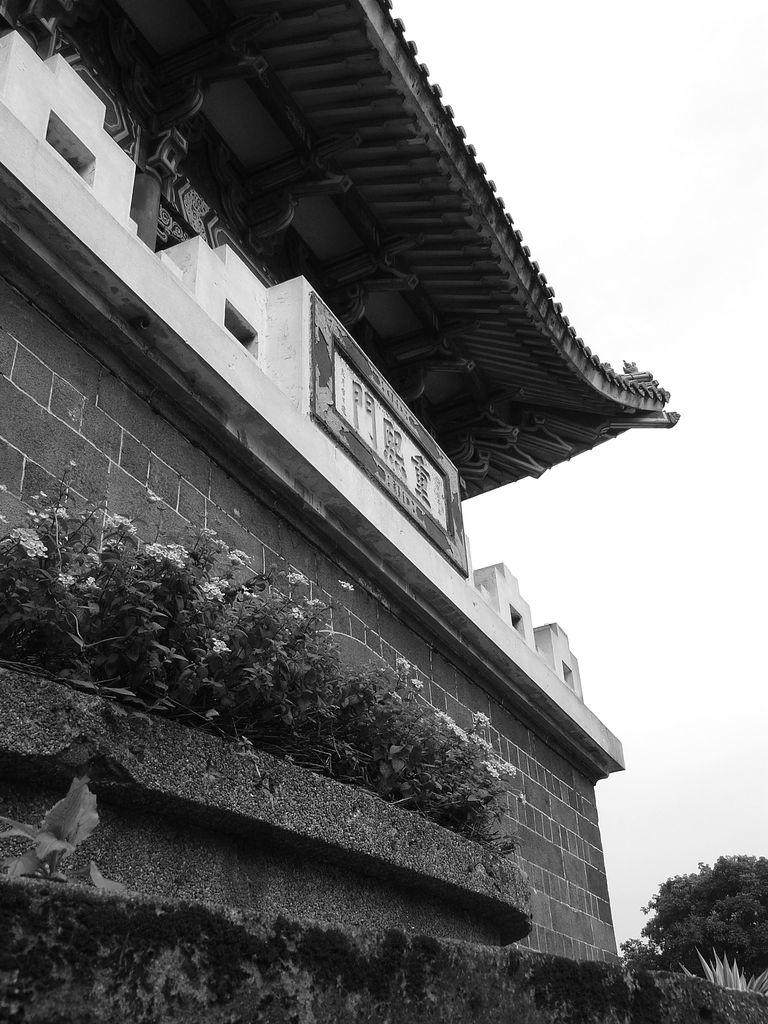What type of structure is present in the image? There is a building in the image. What is located in front of the building? There are plants with flowers in front of the building. Where can more plants and trees be found in the image? Plants and trees can be found at the bottom right corner of the image. What part of the building is visible in the image? The wall is visible in the image. What can be seen on the right side of the image? The sky is visible on the right side of the image. How many coaches are parked in front of the building in the image? There are no coaches present in the image; only plants with flowers are located in front of the building. 